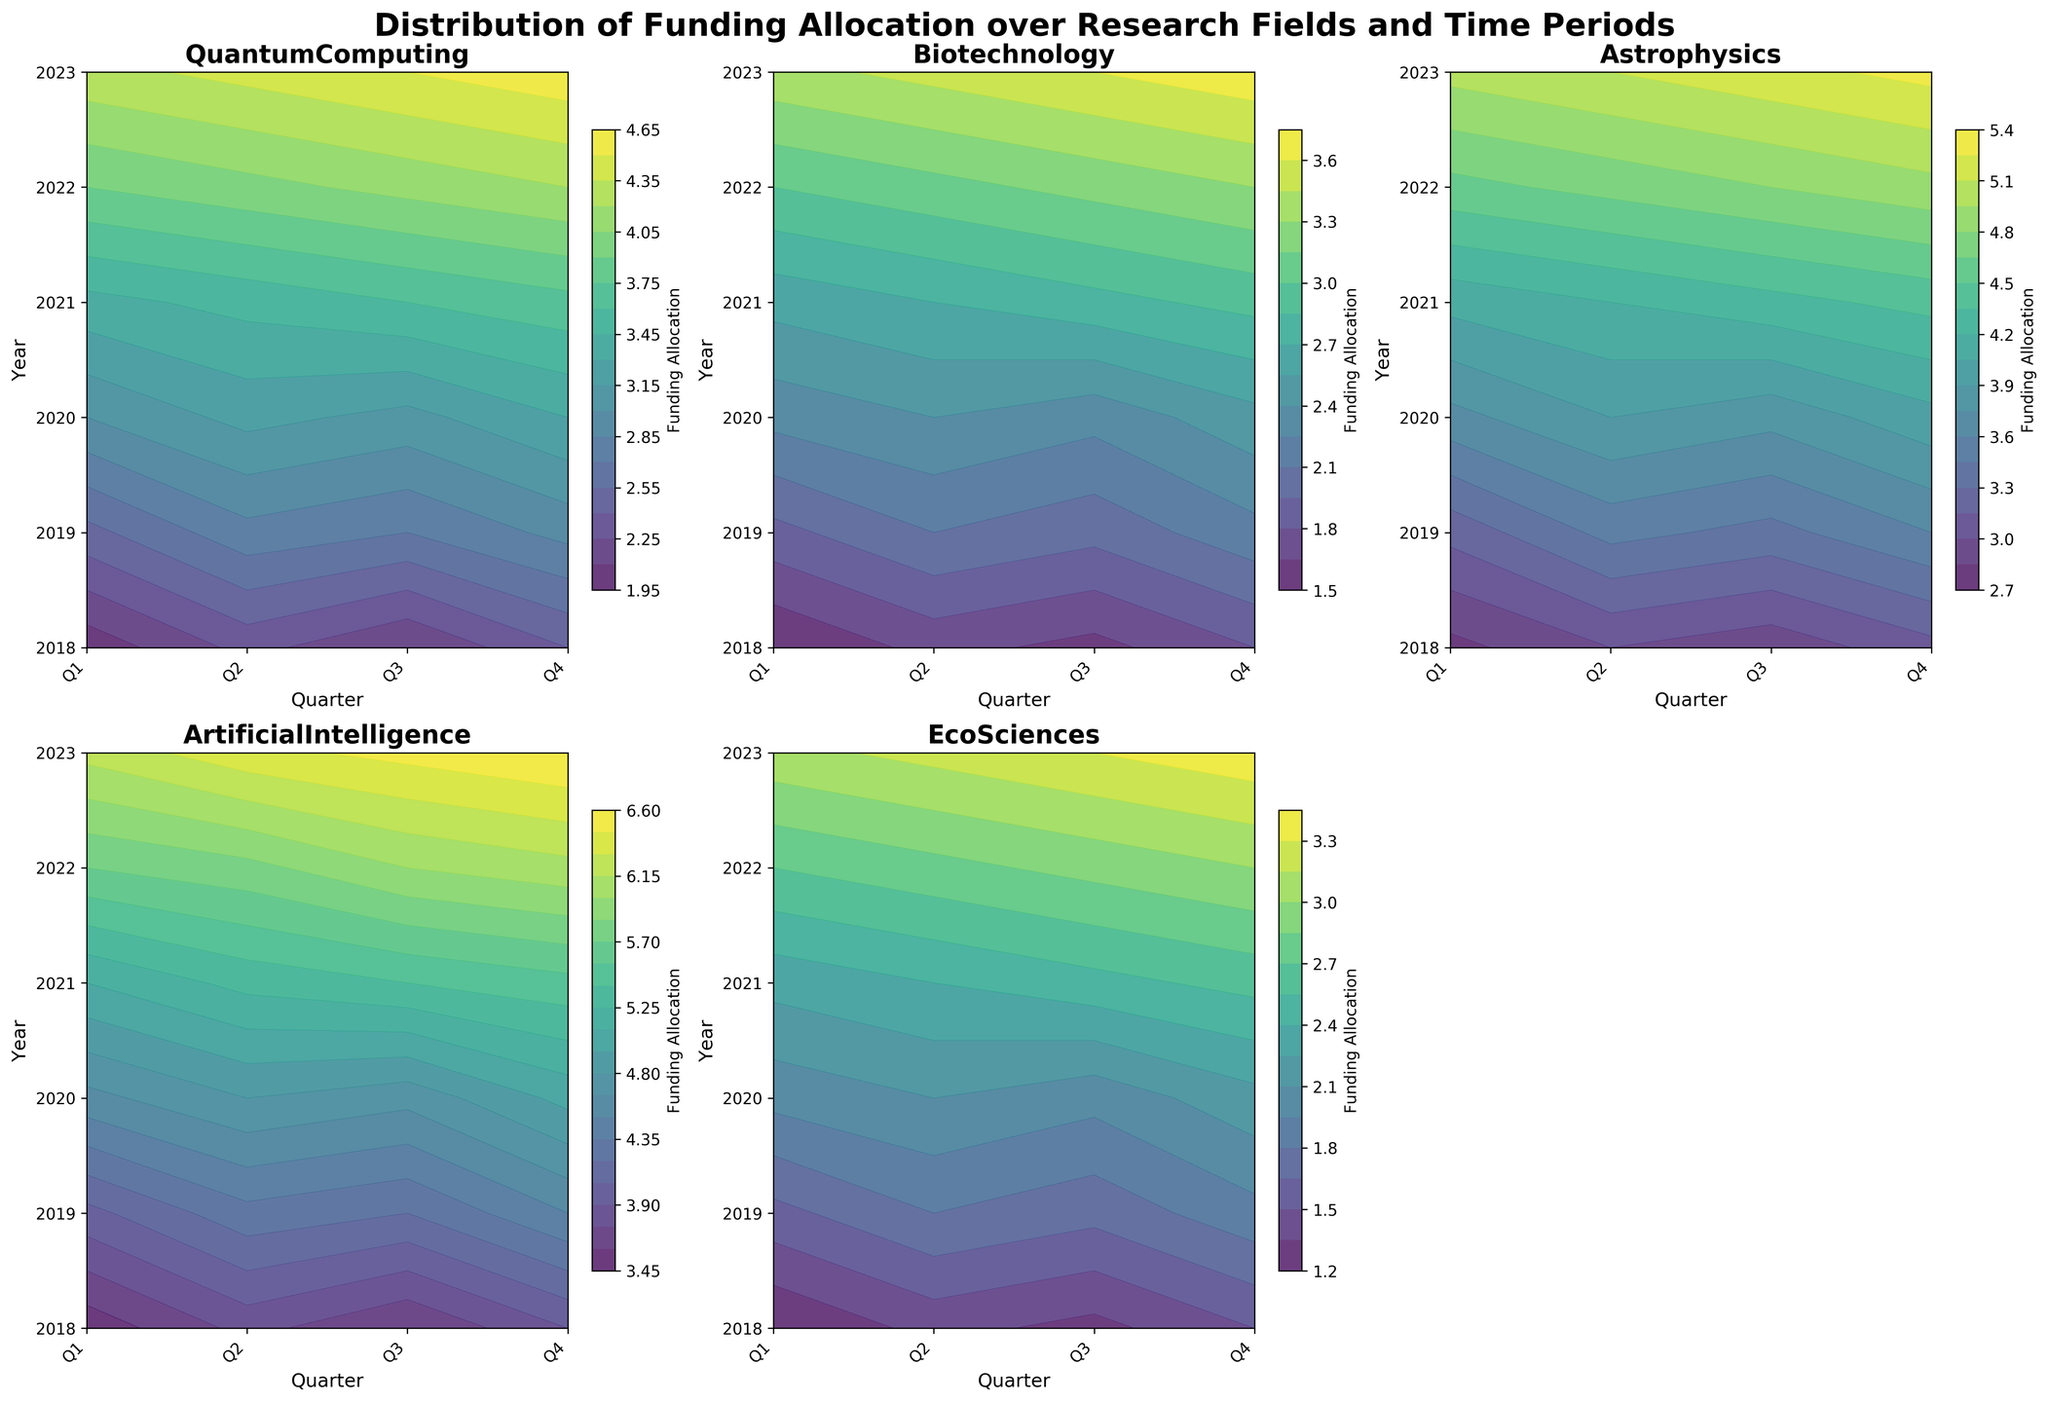What's the title of the figure? The title is usually located at the top of the figure. Here, it states "Distribution of Funding Allocation over Research Fields and Time Periods".
Answer: Distribution of Funding Allocation over Research Fields and Time Periods Which research field shows the highest range of funding allocation over the time periods? By visually scanning the contour plots, we notice that the color gradient is most pronounced for "Artificial Intelligence," indicating a wider range of funding allocation values compared to other fields.
Answer: Artificial Intelligence What years and quarters are on the x and y axes, respectively? The x-axis represents the quarters (Q1 to Q4), and the y-axis shows the years (from 2018 to 2023).
Answer: Years: 2018 to 2023, Quarters: Q1 to Q4 Which field showed the highest funding allocation in 2023 Q4? By looking at the 2023 row and the Q4 column for each plot, "Artificial Intelligence" has the highest funding allocation with a contour gradient indicating higher values.
Answer: Artificial Intelligence In comparison to 'Biotechnology', did 'EcoSciences' have lower or higher funding in Q3 of 2023? Locating Q3 of 2023 (the third quarter of the last year) in both "Biotechnology" and "EcoSciences" plots, "EcoSciences" has a funding allocation of 3.3 while "Biotechnology" has 3.6. Therefore, "EcoSciences" had lower funding.
Answer: Lower What trend in funding do you observe for 'Quantum Computing' over the time period? The gradient in the contour plot for "Quantum Computing" consistently moves towards higher values from 2018 to 2023, indicating an increasing trend in funding over time.
Answer: Increasing How does the funding allocation in 'Astrophysics' compare between Q1 of 2018 and Q1 of 2023? Checking the contour plot for "Astrophysics" at Q1 of both 2018 and 2023, the value has increased from 2.8 in 2018 to 5.0 in 2023.
Answer: Increased What is the average funding allocation for 'Artificial Intelligence' in 2020? On the "Artificial Intelligence" plot, average the values for all four quarters in 2020: (4.6 + 4.8 + 4.7 + 5.0) / 4 = 19.1 / 4 = 4.775.
Answer: 4.775 How does funding allocation in 'Biotechnology' change from Q1 to Q4 in a single year, say 2021? For "Biotechnology" in 2021, the funding allocation changes as follows: Q1 (2.6), Q2 (2.7), Q3 (2.8), Q4 (2.9). It consistently increases each quarter within the year.
Answer: Increases 